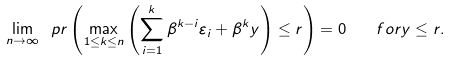<formula> <loc_0><loc_0><loc_500><loc_500>\lim _ { n \rightarrow \infty } \ p r \left ( \max _ { 1 \leq k \leq n } \left ( \sum _ { i = 1 } ^ { k } \beta ^ { k - i } \varepsilon _ { i } + \beta ^ { k } y \right ) \leq r \right ) = 0 \quad f o r y \leq r .</formula> 